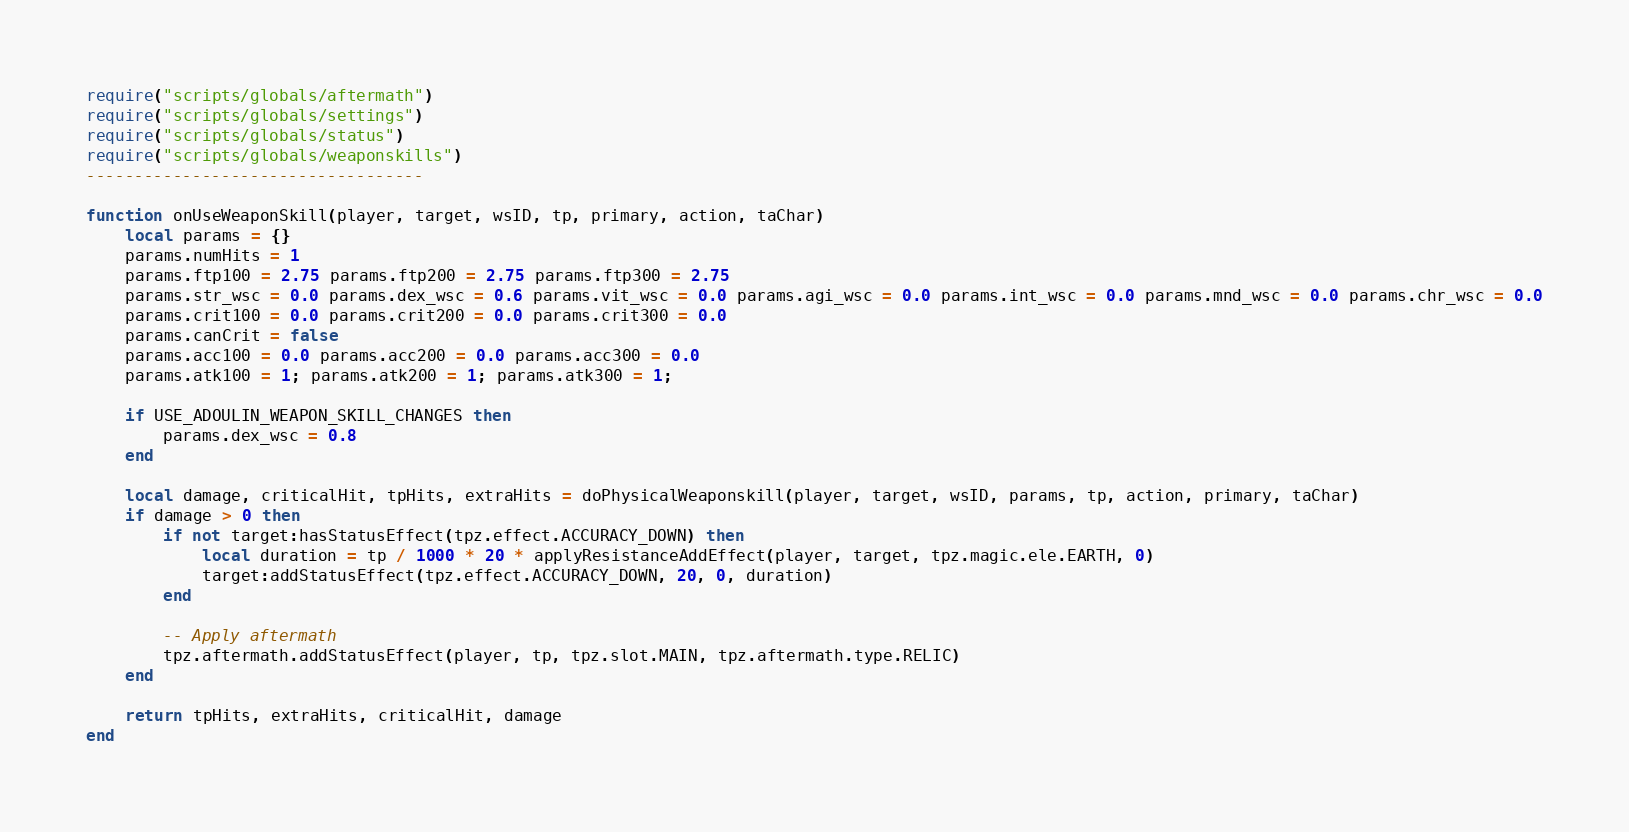Convert code to text. <code><loc_0><loc_0><loc_500><loc_500><_Lua_>require("scripts/globals/aftermath")
require("scripts/globals/settings")
require("scripts/globals/status")
require("scripts/globals/weaponskills")
-----------------------------------

function onUseWeaponSkill(player, target, wsID, tp, primary, action, taChar)
    local params = {}
    params.numHits = 1
    params.ftp100 = 2.75 params.ftp200 = 2.75 params.ftp300 = 2.75
    params.str_wsc = 0.0 params.dex_wsc = 0.6 params.vit_wsc = 0.0 params.agi_wsc = 0.0 params.int_wsc = 0.0 params.mnd_wsc = 0.0 params.chr_wsc = 0.0
    params.crit100 = 0.0 params.crit200 = 0.0 params.crit300 = 0.0
    params.canCrit = false
    params.acc100 = 0.0 params.acc200 = 0.0 params.acc300 = 0.0
    params.atk100 = 1; params.atk200 = 1; params.atk300 = 1;

    if USE_ADOULIN_WEAPON_SKILL_CHANGES then
        params.dex_wsc = 0.8
    end

    local damage, criticalHit, tpHits, extraHits = doPhysicalWeaponskill(player, target, wsID, params, tp, action, primary, taChar)
    if damage > 0 then
        if not target:hasStatusEffect(tpz.effect.ACCURACY_DOWN) then
            local duration = tp / 1000 * 20 * applyResistanceAddEffect(player, target, tpz.magic.ele.EARTH, 0)
            target:addStatusEffect(tpz.effect.ACCURACY_DOWN, 20, 0, duration)
        end

        -- Apply aftermath
        tpz.aftermath.addStatusEffect(player, tp, tpz.slot.MAIN, tpz.aftermath.type.RELIC)
    end

    return tpHits, extraHits, criticalHit, damage
end
</code> 